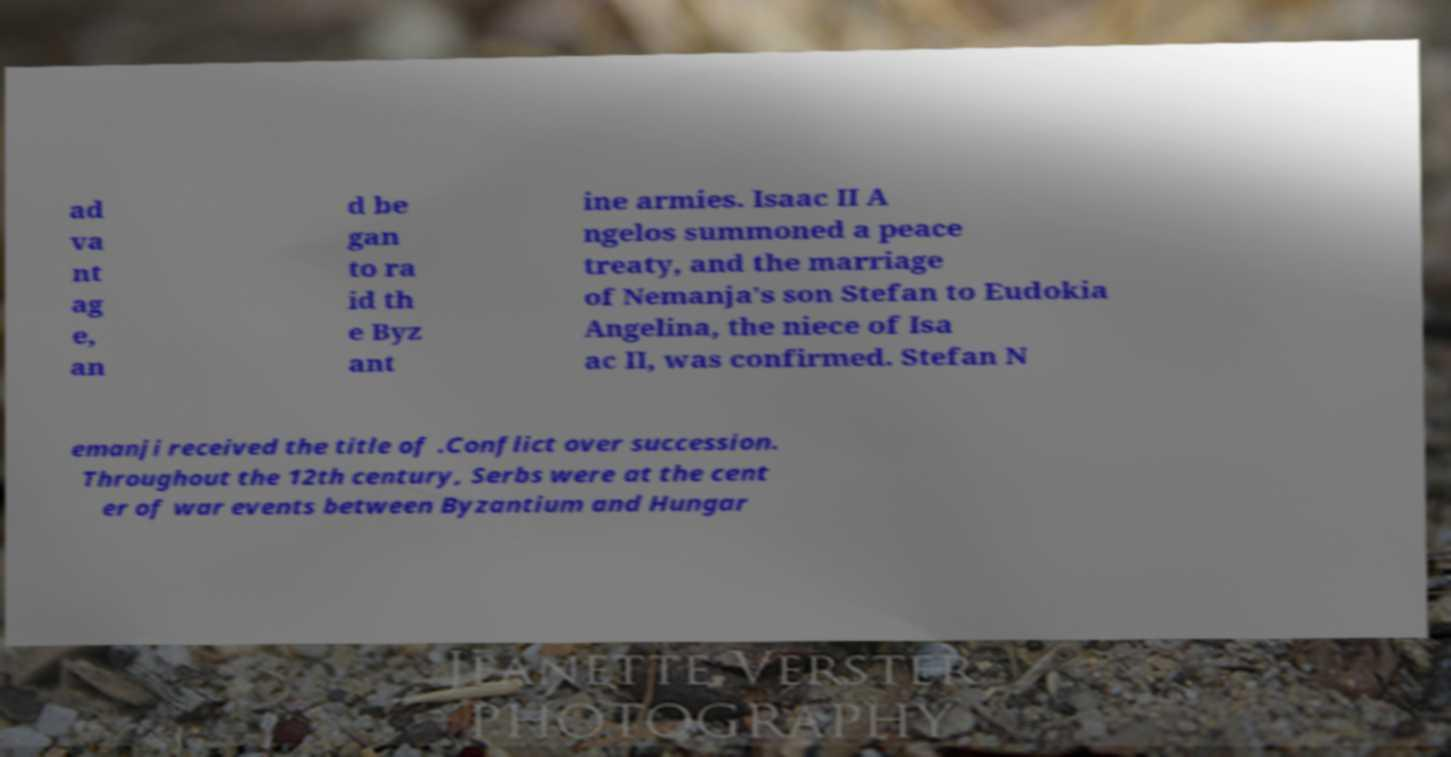Please identify and transcribe the text found in this image. ad va nt ag e, an d be gan to ra id th e Byz ant ine armies. Isaac II A ngelos summoned a peace treaty, and the marriage of Nemanja's son Stefan to Eudokia Angelina, the niece of Isa ac II, was confirmed. Stefan N emanji received the title of .Conflict over succession. Throughout the 12th century, Serbs were at the cent er of war events between Byzantium and Hungar 